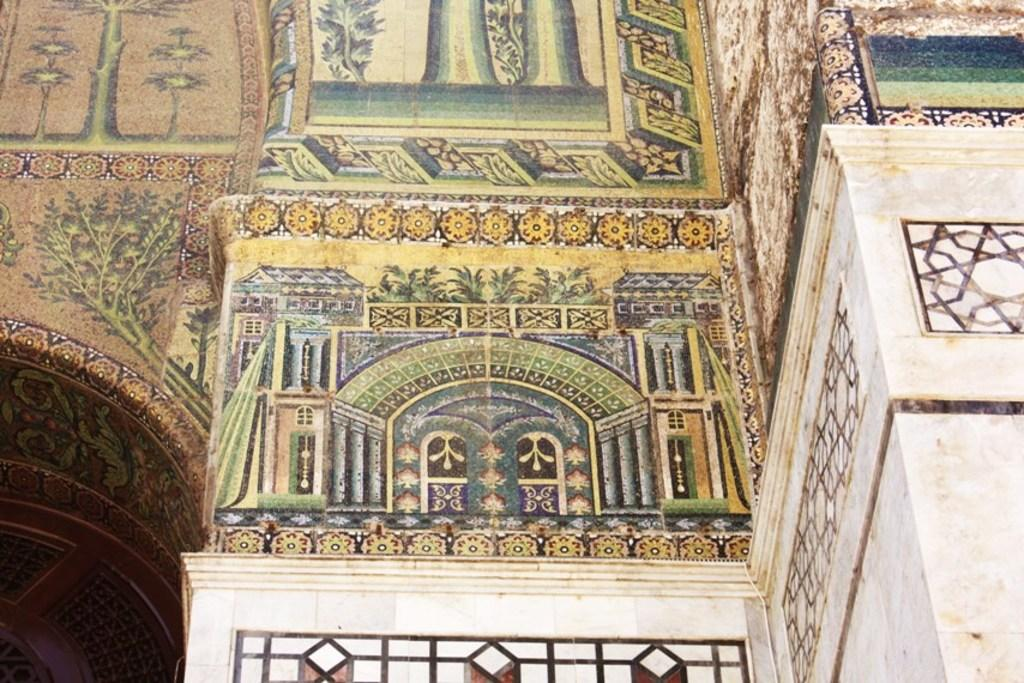What is present on the wall in the image? There are paintings on the wall in the image. Can you describe the paintings on the wall? Unfortunately, the details of the paintings cannot be determined from the image alone. What is the primary function of the wall in the image? The wall serves as a surface for displaying the paintings. How many jellyfish are swimming in the painting on the left side of the wall? There are no jellyfish present in the image, as it only features paintings on the wall. What type of bell is hanging from the painting on the right side of the wall? There is no bell present in the image; it only features paintings on the wall. 